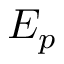Convert formula to latex. <formula><loc_0><loc_0><loc_500><loc_500>E _ { p }</formula> 